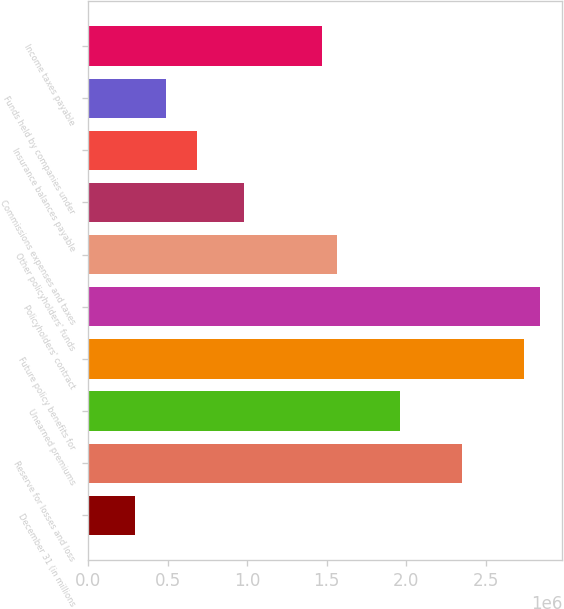<chart> <loc_0><loc_0><loc_500><loc_500><bar_chart><fcel>December 31 (in millions<fcel>Reserve for losses and loss<fcel>Unearned premiums<fcel>Future policy benefits for<fcel>Policyholders' contract<fcel>Other policyholders' funds<fcel>Commissions expenses and taxes<fcel>Insurance balances payable<fcel>Funds held by companies under<fcel>Income taxes payable<nl><fcel>293958<fcel>2.35033e+06<fcel>1.95864e+06<fcel>2.74202e+06<fcel>2.83994e+06<fcel>1.56695e+06<fcel>979414<fcel>685647<fcel>489802<fcel>1.46903e+06<nl></chart> 